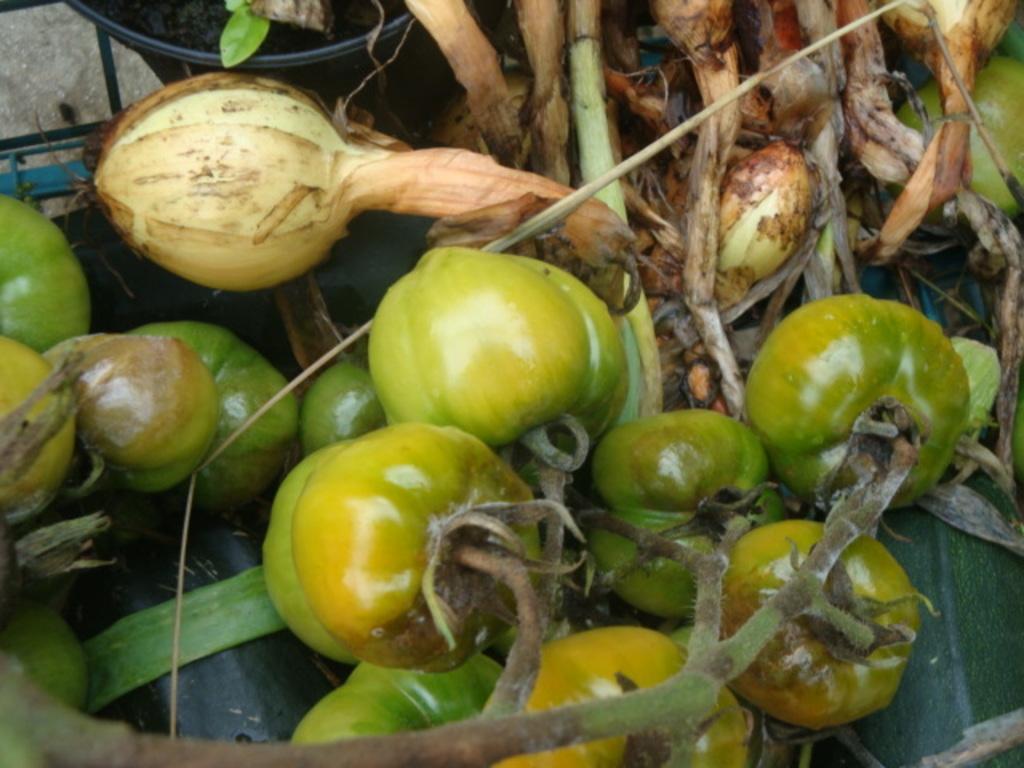Describe this image in one or two sentences. There are tomatoes and other vegetables. 